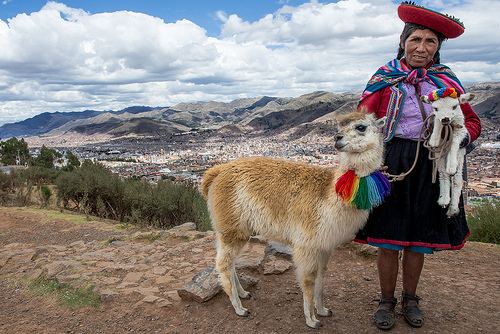<image>
Is the sky under the mountain? No. The sky is not positioned under the mountain. The vertical relationship between these objects is different. Is there a collar on the alpaca? Yes. Looking at the image, I can see the collar is positioned on top of the alpaca, with the alpaca providing support. Where is the sheep in relation to the ground? Is it on the ground? No. The sheep is not positioned on the ground. They may be near each other, but the sheep is not supported by or resting on top of the ground. 